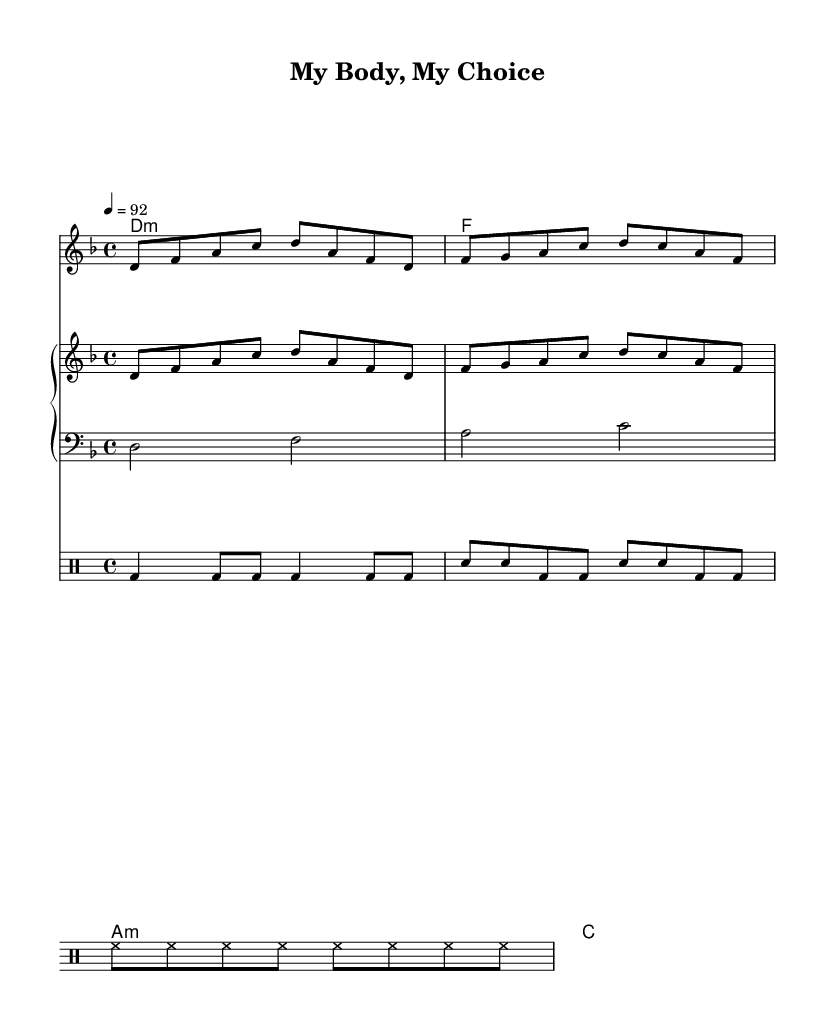What is the key signature of this music? The key signature is D minor, which includes one flat. This can be identified by looking at the key signature at the beginning of the staff.
Answer: D minor What is the time signature of this music? The time signature is 4/4, indicating four beats per measure. This is present at the beginning of the score, indicating the rhythmic structure of the piece.
Answer: 4/4 What is the tempo marking for this piece? The tempo marking is 4 = 92, which indicates that there are 92 beats per minute. This is found at the beginning of the score, defining how fast the music should be performed.
Answer: 92 What is the title of this composition? The title "My Body, My Choice" can be found at the top of the sheet music, indicating the overall theme or message of the piece.
Answer: My Body, My Choice How many measures are there in the vocal melody? The vocal melody consists of 4 measures based on the grouping of notes presented in the melody line. Each measure is defined by the vertical lines on the staff.
Answer: 4 What is the main message conveyed in the chorus? The main message in the chorus emphasizes the notion of bodily autonomy. This is evident in the lyrics provided for the chorus part.
Answer: My body, my choice What type of percussion is illustrated in the drum pattern? The drum pattern showcases a bass drum, snare drum, and hi-hat. Each instrument is designated within the drum staff, indicating the various components of the rhythm section.
Answer: Bass drum, snare drum, hi-hat 